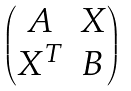Convert formula to latex. <formula><loc_0><loc_0><loc_500><loc_500>\begin{pmatrix} A & X \\ X ^ { T } & B \end{pmatrix}</formula> 